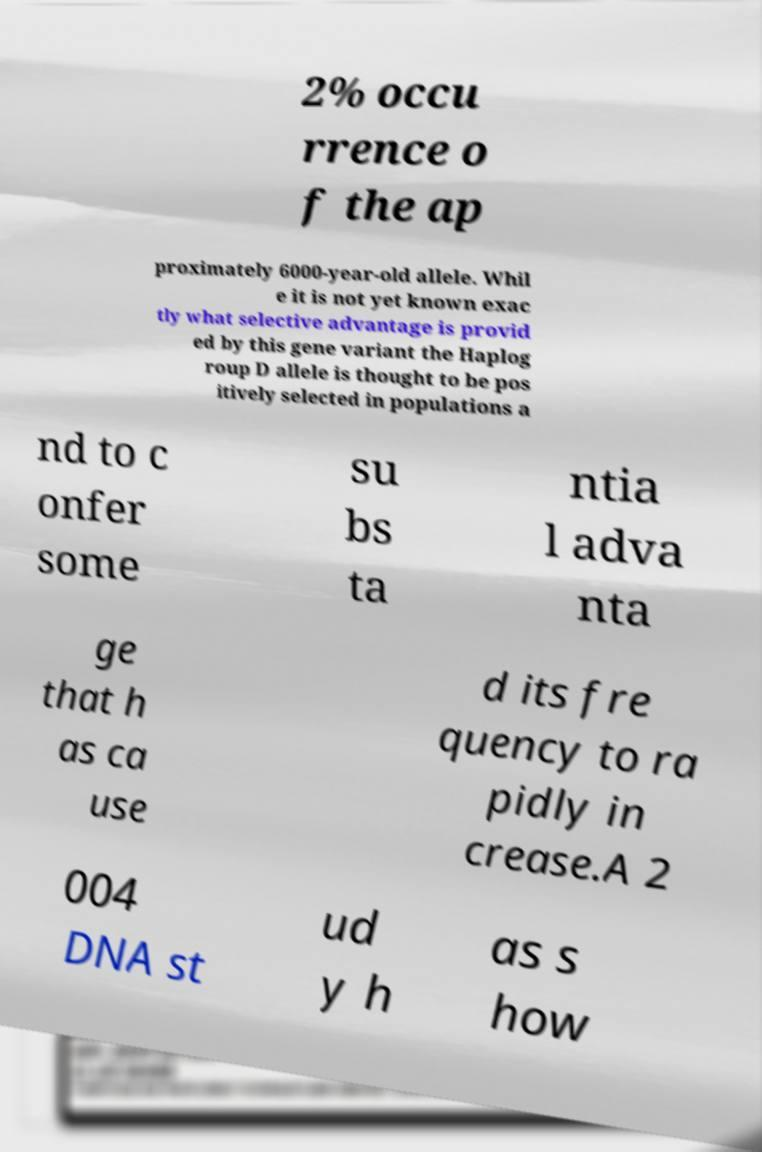There's text embedded in this image that I need extracted. Can you transcribe it verbatim? 2% occu rrence o f the ap proximately 6000-year-old allele. Whil e it is not yet known exac tly what selective advantage is provid ed by this gene variant the Haplog roup D allele is thought to be pos itively selected in populations a nd to c onfer some su bs ta ntia l adva nta ge that h as ca use d its fre quency to ra pidly in crease.A 2 004 DNA st ud y h as s how 